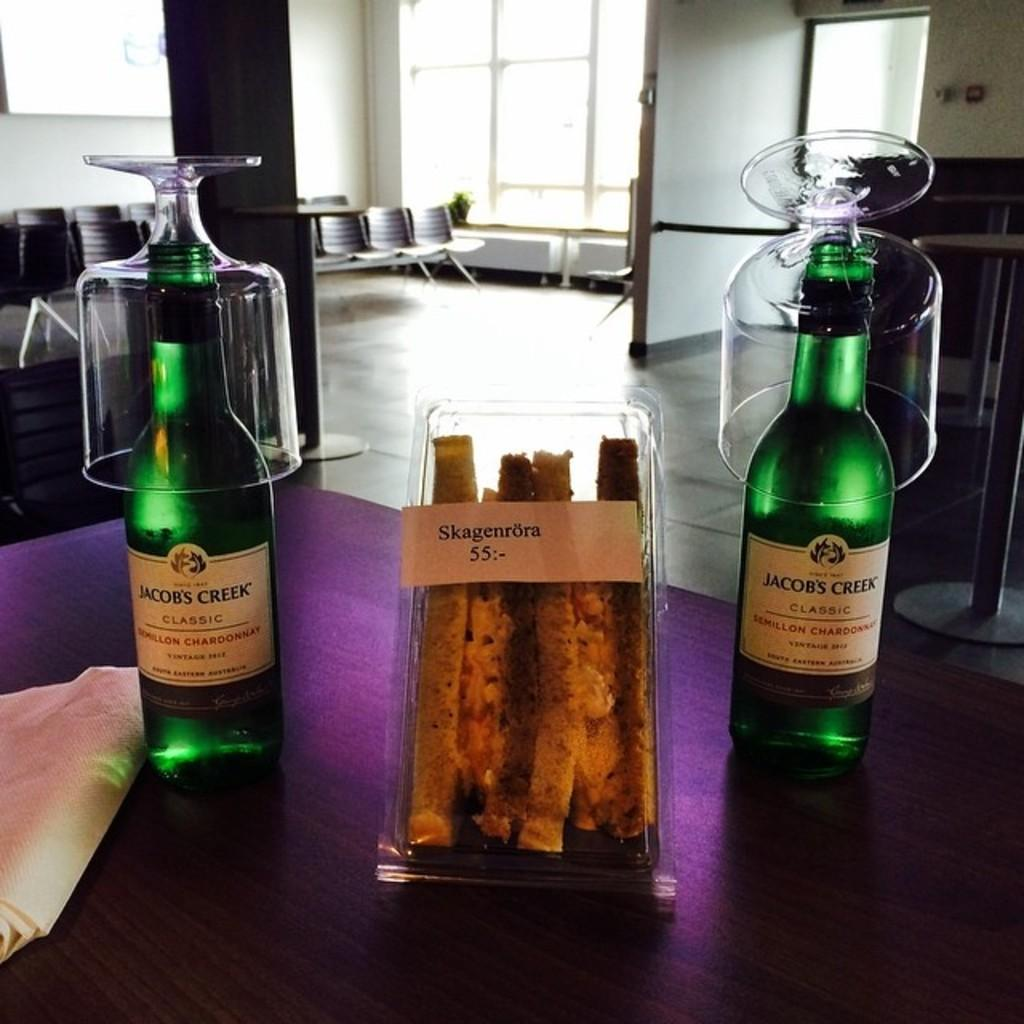<image>
Offer a succinct explanation of the picture presented. Two bottles of Jacob's Creek Classic Chardonnay wine with a package of sandwiches. 